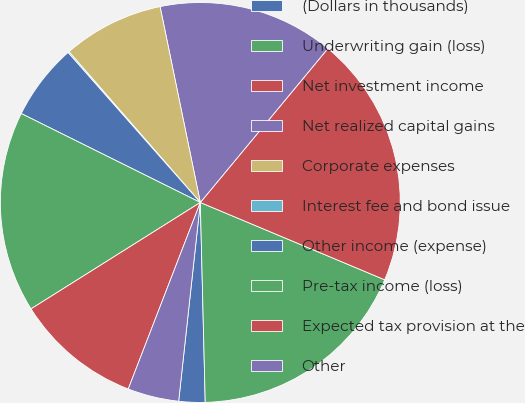<chart> <loc_0><loc_0><loc_500><loc_500><pie_chart><fcel>(Dollars in thousands)<fcel>Underwriting gain (loss)<fcel>Net investment income<fcel>Net realized capital gains<fcel>Corporate expenses<fcel>Interest fee and bond issue<fcel>Other income (expense)<fcel>Pre-tax income (loss)<fcel>Expected tax provision at the<fcel>Other<nl><fcel>2.12%<fcel>18.29%<fcel>20.31%<fcel>14.24%<fcel>8.18%<fcel>0.1%<fcel>6.16%<fcel>16.27%<fcel>10.2%<fcel>4.14%<nl></chart> 